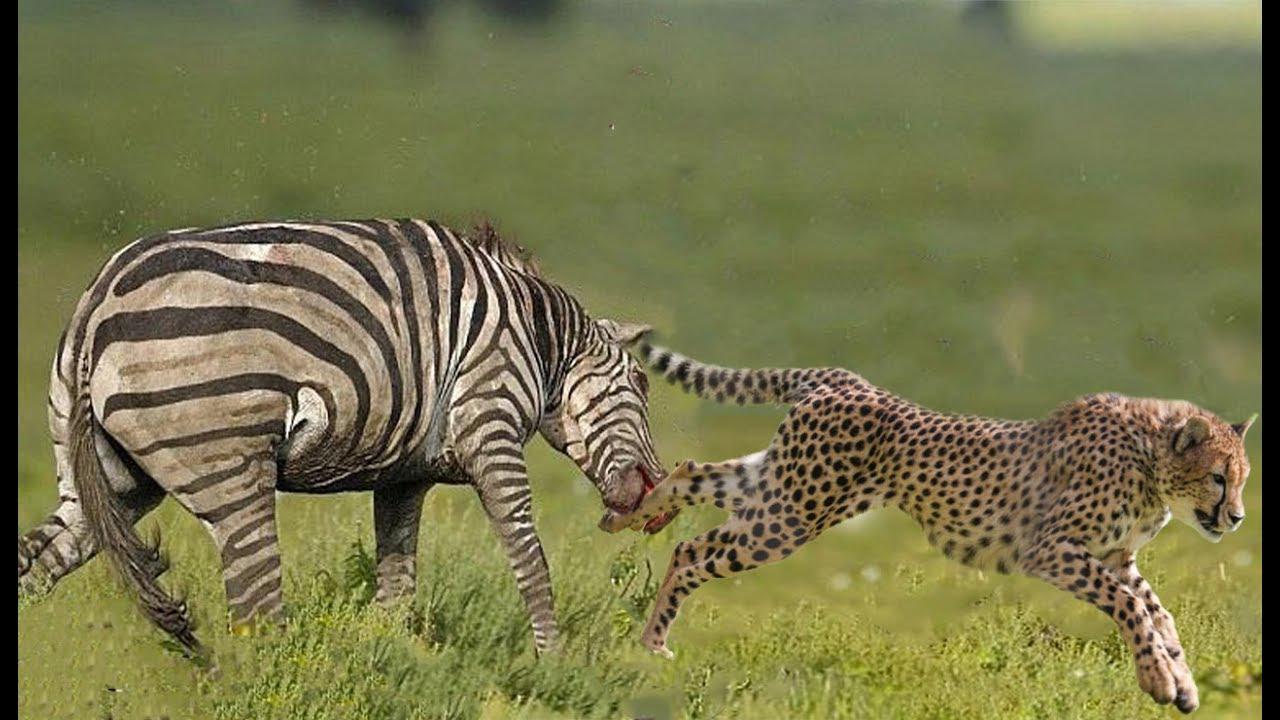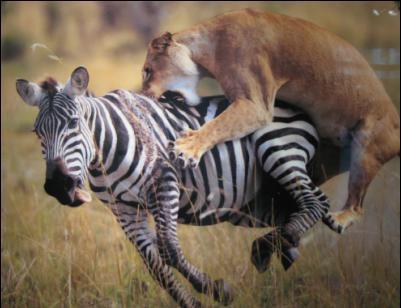The first image is the image on the left, the second image is the image on the right. Assess this claim about the two images: "There are animals fighting.". Correct or not? Answer yes or no. Yes. The first image is the image on the left, the second image is the image on the right. For the images displayed, is the sentence "A lion is pouncing on a zebra in one of the images." factually correct? Answer yes or no. Yes. 